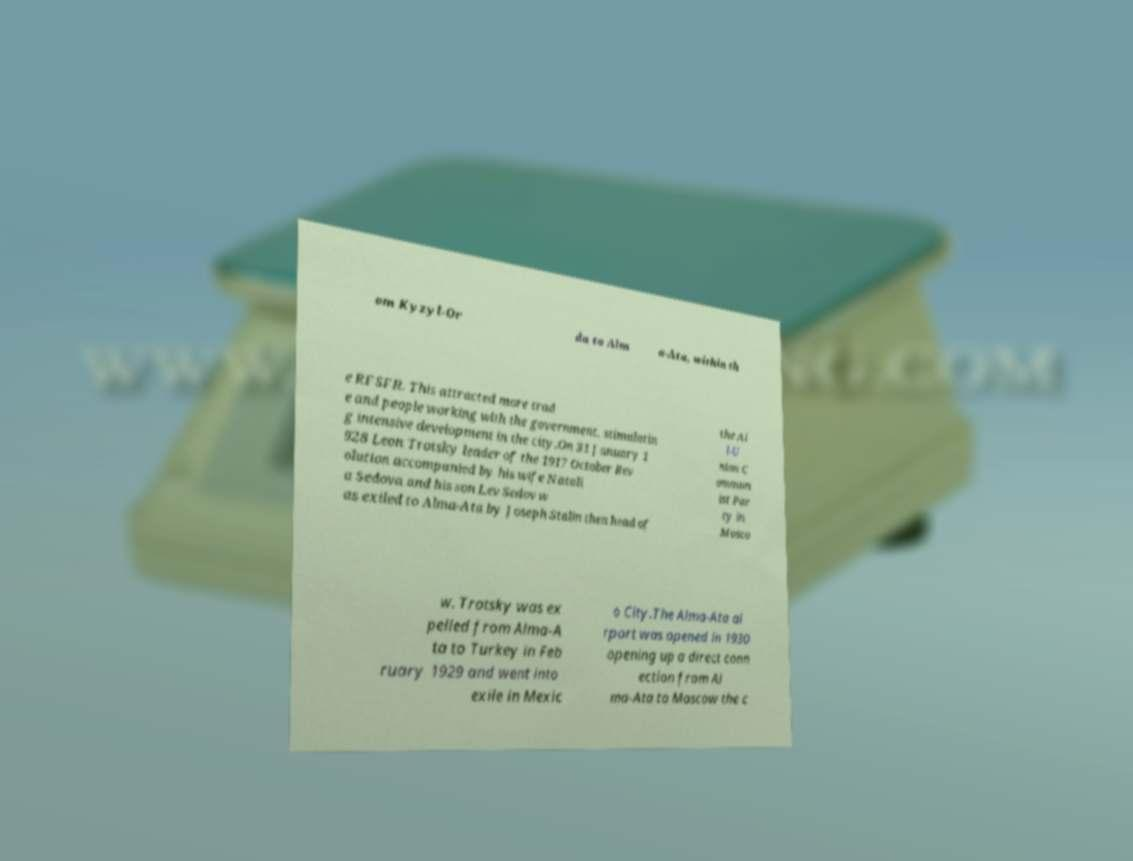Please read and relay the text visible in this image. What does it say? om Kyzyl-Or da to Alm a-Ata, within th e RFSFR. This attracted more trad e and people working with the government, stimulatin g intensive development in the city.On 31 January 1 928 Leon Trotsky leader of the 1917 October Rev olution accompanied by his wife Natali a Sedova and his son Lev Sedov w as exiled to Alma-Ata by Joseph Stalin then head of the Al l-U nion C ommun ist Par ty in Mosco w. Trotsky was ex pelled from Alma-A ta to Turkey in Feb ruary 1929 and went into exile in Mexic o City.The Alma-Ata ai rport was opened in 1930 opening up a direct conn ection from Al ma-Ata to Moscow the c 